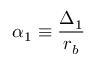Convert formula to latex. <formula><loc_0><loc_0><loc_500><loc_500>\alpha _ { 1 } \equiv \frac { \Delta _ { 1 } } { r _ { b } }</formula> 